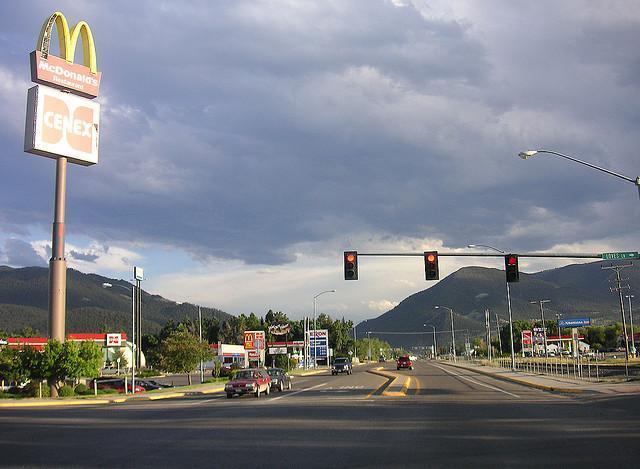How many birds are in the air?
Give a very brief answer. 0. 